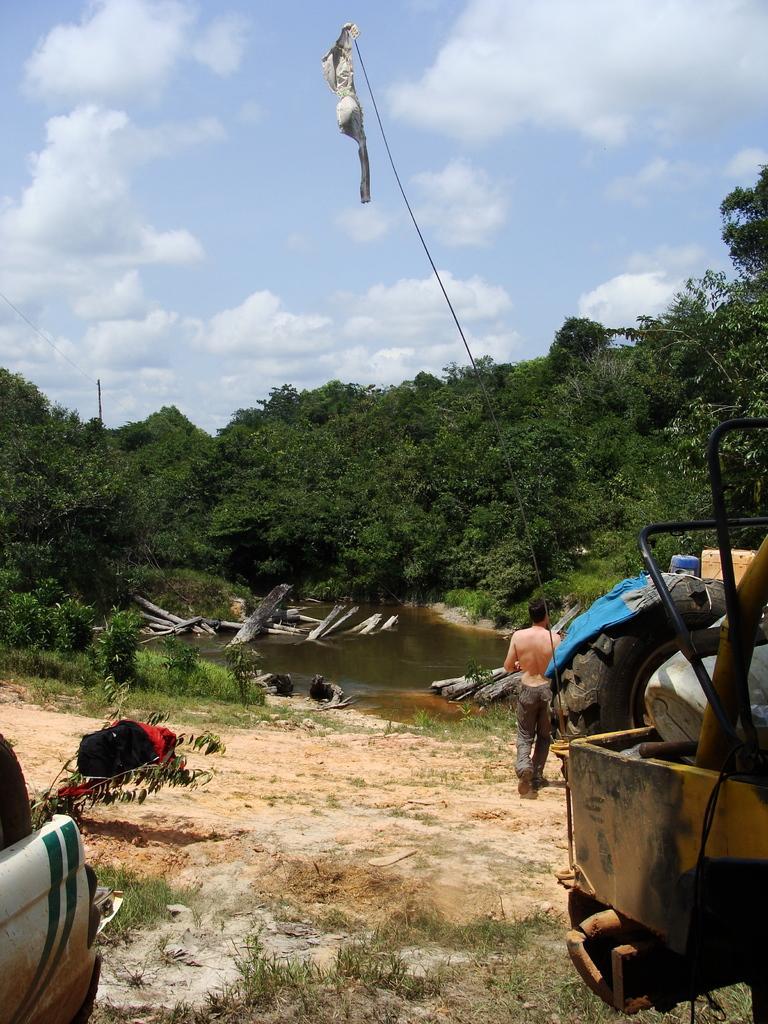How would you summarize this image in a sentence or two? In this image a person is walking on the land having some grass and plants. There are few wooden trunks in the water. Right side there is a vehicle having few objects in it. Behind there is a vehicle on the land. Background there are few trees. Right bottom there is a vehicle. Top of the image there is sky with some clouds. 